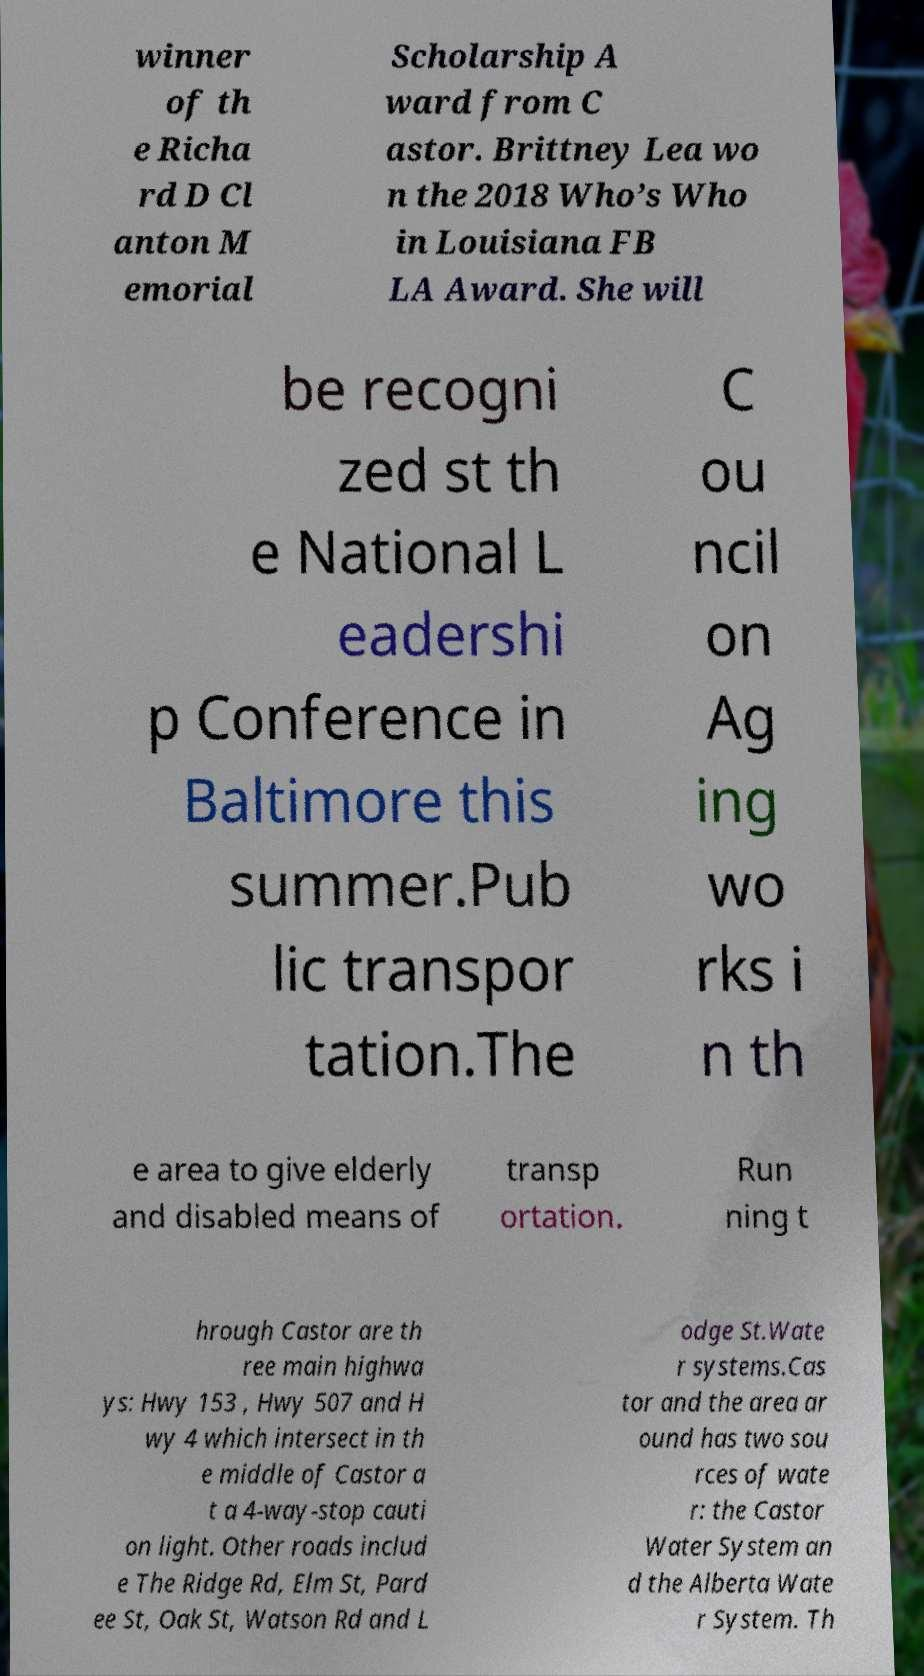Can you read and provide the text displayed in the image?This photo seems to have some interesting text. Can you extract and type it out for me? winner of th e Richa rd D Cl anton M emorial Scholarship A ward from C astor. Brittney Lea wo n the 2018 Who’s Who in Louisiana FB LA Award. She will be recogni zed st th e National L eadershi p Conference in Baltimore this summer.Pub lic transpor tation.The C ou ncil on Ag ing wo rks i n th e area to give elderly and disabled means of transp ortation. Run ning t hrough Castor are th ree main highwa ys: Hwy 153 , Hwy 507 and H wy 4 which intersect in th e middle of Castor a t a 4-way-stop cauti on light. Other roads includ e The Ridge Rd, Elm St, Pard ee St, Oak St, Watson Rd and L odge St.Wate r systems.Cas tor and the area ar ound has two sou rces of wate r: the Castor Water System an d the Alberta Wate r System. Th 